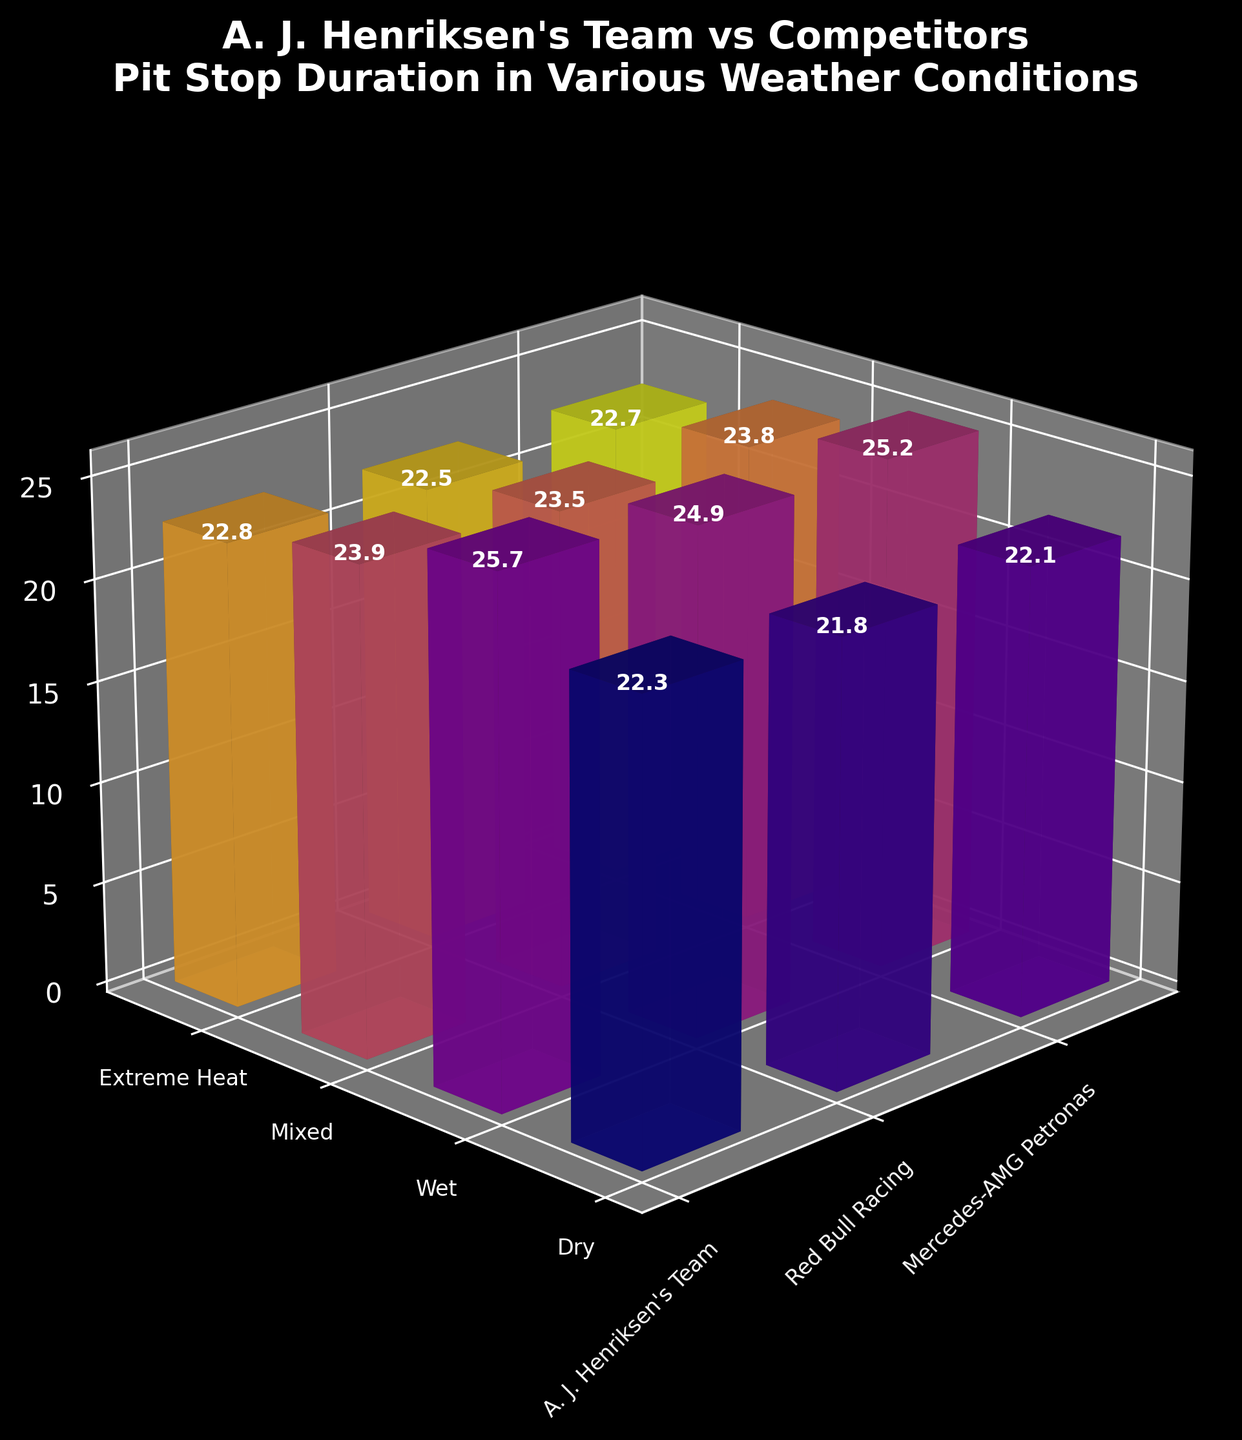How many teams are displayed in the figure? The figure has axes representing different teams for different weather conditions. Checking the x-axis labels, we see three distinct teams: A. J. Henriksen's Team, Red Bull Racing, and Mercedes-AMG Petronas.
Answer: 3 What is the lowest pit stop duration recorded under dry conditions? Observing the bars for dry weather conditions on the y-axis, the shortest bar represents Red Bull Racing with a pit stop duration of 21.8 seconds.
Answer: 21.8 seconds Does A. J. Henriksen's Team have the fastest pit stop duration in any weather condition? Comparing the heights of the bars for A. J. Henriksen's Team with the competitors across different weather conditions, none of A. J. Henriksen's bars are the shortest in any category.
Answer: No Which team had the longest pit stop duration in wet conditions? By looking at the bars representing wet conditions, A. J. Henriksen's Team has the highest bar, indicating the longest pit stop duration of 25.7 seconds.
Answer: A. J. Henriksen's Team What is the difference in pit stop duration between A. J. Henriksen's Team and Red Bull Racing in mixed conditions? In mixed weather conditions, the pit stop durations are 23.9 seconds for A. J. Henriksen's Team and 23.5 seconds for Red Bull Racing. The difference is 23.9 - 23.5 = 0.4 seconds.
Answer: 0.4 seconds Which weather condition shows the smallest range of pit stop durations across all teams? Observing the variation in bar heights across different weather conditions, extreme heat shows bars of similar height: A. J. Henriksen's Team (22.8), Red Bull Racing (22.5), and Mercedes-AMG Petronas (22.7). The range is 22.8 - 22.5 = 0.3 seconds. This range is smaller compared to other conditions.
Answer: Extreme Heat What is the average pit stop duration for Mercedes-AMG Petronas across all weather conditions? Summing the pit stop durations for Mercedes-AMG Petronas in each condition: 22.1 (Dry) + 25.2 (Wet) + 23.8 (Mixed) + 22.7 (Extreme Heat) = 93.8, then dividing by the number of conditions (4) gives 93.8 / 4 = 23.45 seconds.
Answer: 23.45 seconds How do A. J. Henriksen's Team's pit stop durations vary between wet and extreme heat conditions? A. J. Henriksen's Team has a pit stop duration of 25.7 seconds in wet conditions and 22.8 seconds in extreme heat conditions. The difference is 25.7 - 22.8 = 2.9 seconds.
Answer: 2.9 seconds Which team has the smallest overall increase in pit stop duration when going from dry to wet conditions? Calculating the increase for each team from dry to wet: A. J. Henriksen's Team: 25.7 - 22.3 = 3.4 seconds, Red Bull Racing: 24.9 - 21.8 = 3.1 seconds, Mercedes-AMG Petronas: 25.2 - 22.1 = 3.1 seconds. Red Bull Racing and Mercedes-AMG Petronas both have the smallest increase of 3.1 seconds.
Answer: Red Bull Racing and Mercedes-AMG Petronas 